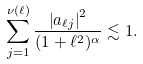Convert formula to latex. <formula><loc_0><loc_0><loc_500><loc_500>\sum _ { j = 1 } ^ { \nu ( \ell ) } \frac { \left | a _ { \ell j } \right | ^ { 2 } } { ( 1 + \ell ^ { 2 } ) ^ { \alpha } } \lesssim 1 .</formula> 